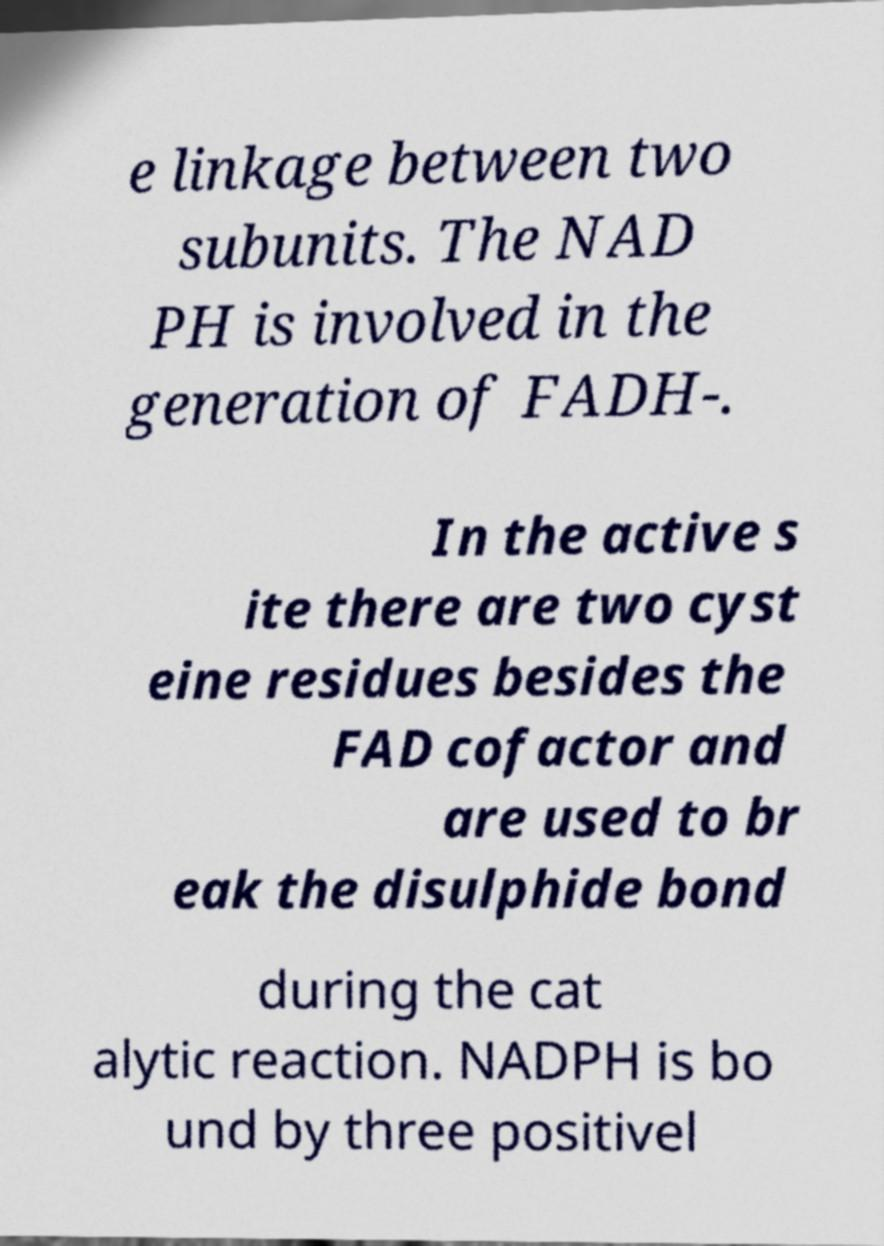Can you accurately transcribe the text from the provided image for me? e linkage between two subunits. The NAD PH is involved in the generation of FADH-. In the active s ite there are two cyst eine residues besides the FAD cofactor and are used to br eak the disulphide bond during the cat alytic reaction. NADPH is bo und by three positivel 